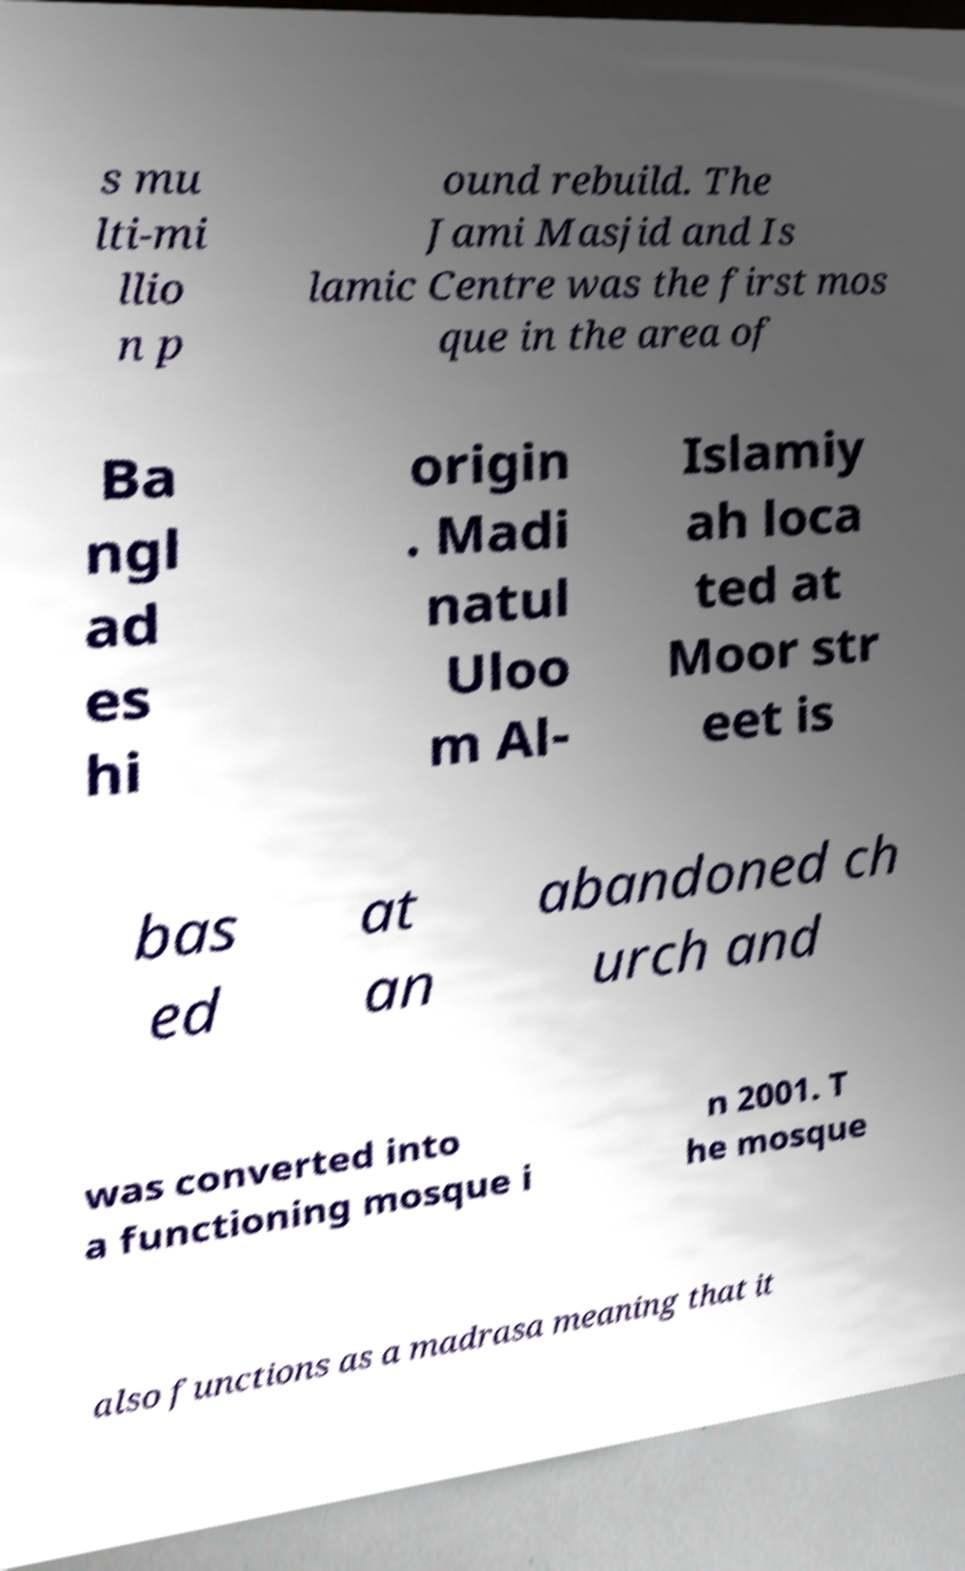For documentation purposes, I need the text within this image transcribed. Could you provide that? s mu lti-mi llio n p ound rebuild. The Jami Masjid and Is lamic Centre was the first mos que in the area of Ba ngl ad es hi origin . Madi natul Uloo m Al- Islamiy ah loca ted at Moor str eet is bas ed at an abandoned ch urch and was converted into a functioning mosque i n 2001. T he mosque also functions as a madrasa meaning that it 